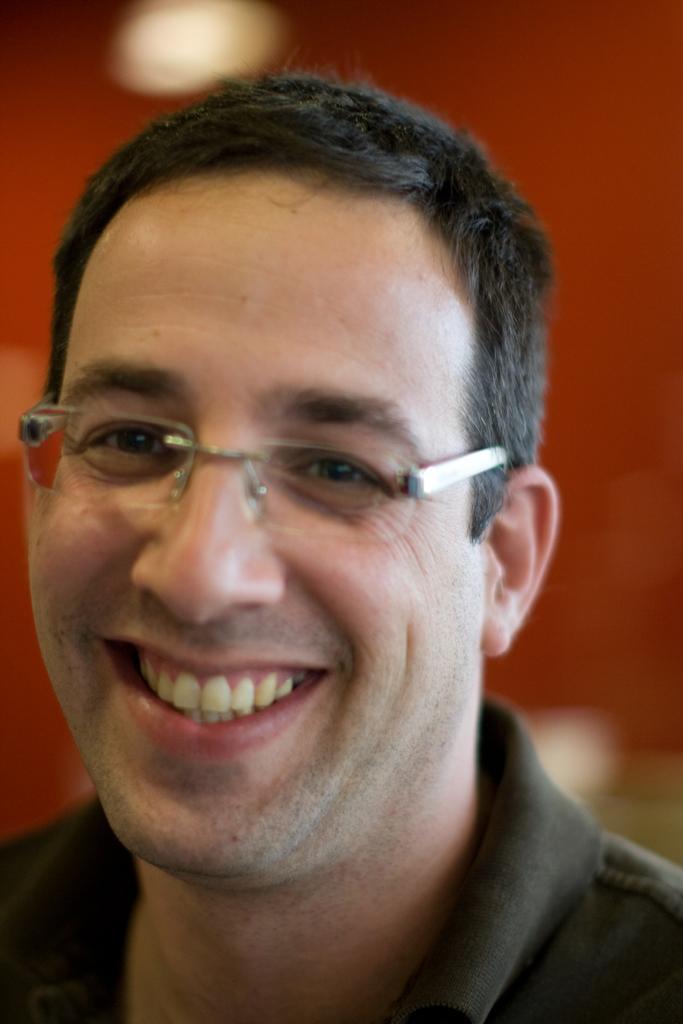Describe this image in one or two sentences. There is a man in the center of the image and the background is blurry. 